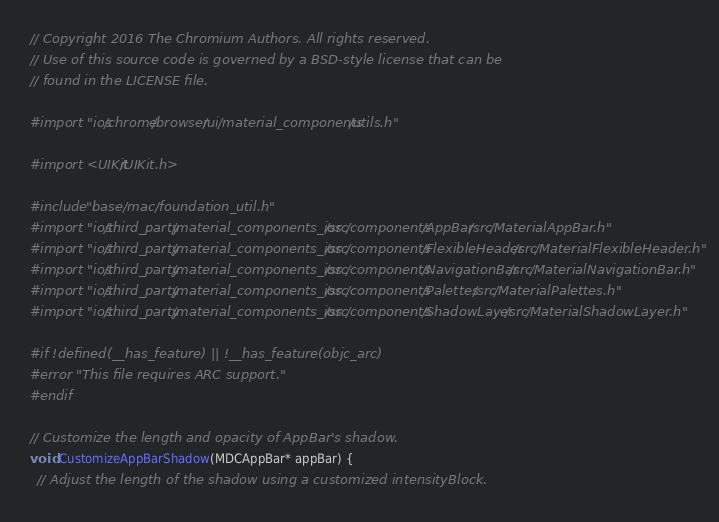Convert code to text. <code><loc_0><loc_0><loc_500><loc_500><_ObjectiveC_>// Copyright 2016 The Chromium Authors. All rights reserved.
// Use of this source code is governed by a BSD-style license that can be
// found in the LICENSE file.

#import "ios/chrome/browser/ui/material_components/utils.h"

#import <UIKit/UIKit.h>

#include "base/mac/foundation_util.h"
#import "ios/third_party/material_components_ios/src/components/AppBar/src/MaterialAppBar.h"
#import "ios/third_party/material_components_ios/src/components/FlexibleHeader/src/MaterialFlexibleHeader.h"
#import "ios/third_party/material_components_ios/src/components/NavigationBar/src/MaterialNavigationBar.h"
#import "ios/third_party/material_components_ios/src/components/Palettes/src/MaterialPalettes.h"
#import "ios/third_party/material_components_ios/src/components/ShadowLayer/src/MaterialShadowLayer.h"

#if !defined(__has_feature) || !__has_feature(objc_arc)
#error "This file requires ARC support."
#endif

// Customize the length and opacity of AppBar's shadow.
void CustomizeAppBarShadow(MDCAppBar* appBar) {
  // Adjust the length of the shadow using a customized intensityBlock.</code> 